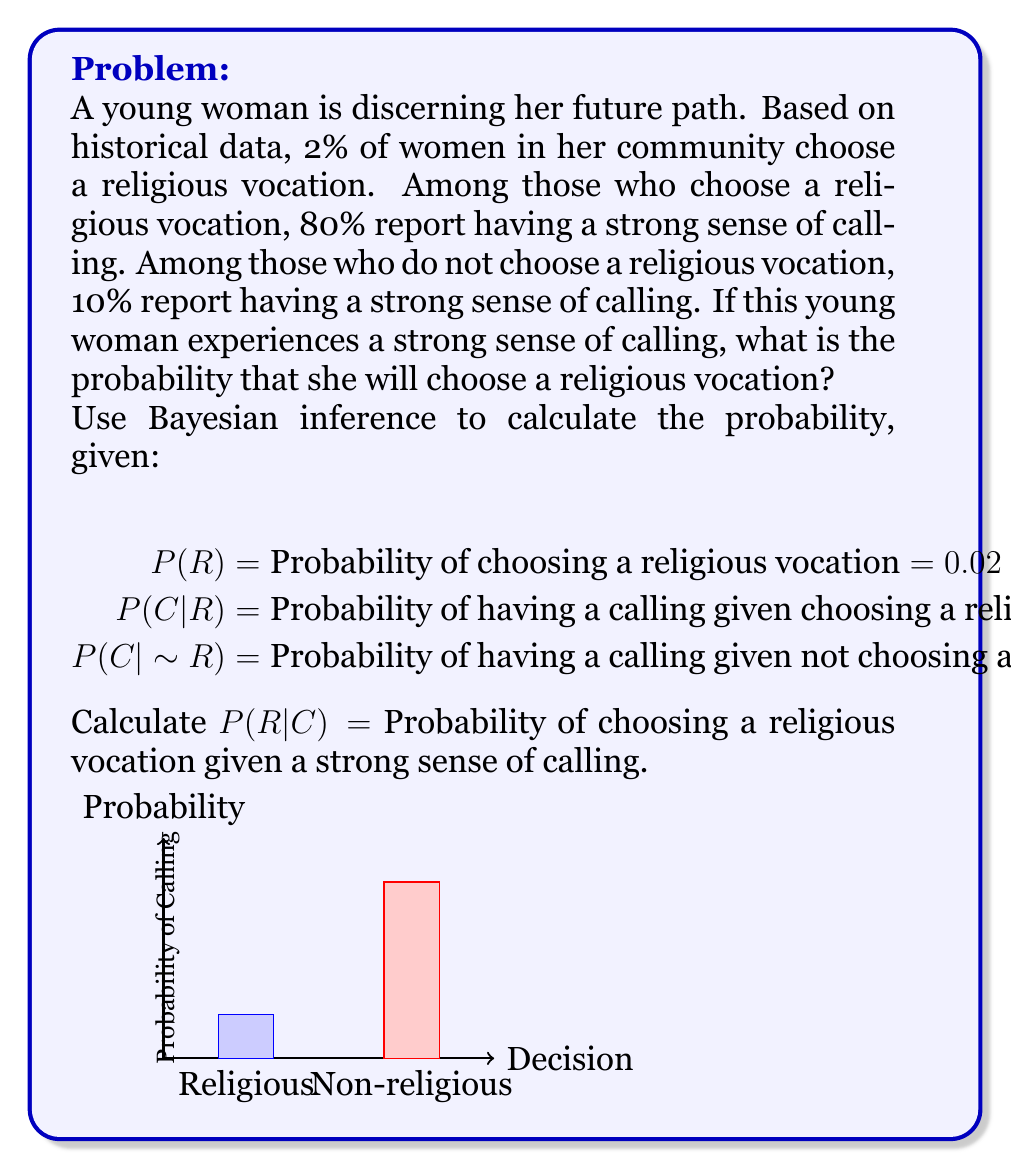Provide a solution to this math problem. To solve this problem using Bayesian inference, we'll use Bayes' theorem:

$$ P(R|C) = \frac{P(C|R) \cdot P(R)}{P(C)} $$

We're given:
P(R) = 0.02
P(C|R) = 0.80
P(C|~R) = 0.10

Step 1: Calculate P(C) using the law of total probability:
$$ P(C) = P(C|R) \cdot P(R) + P(C|~R) \cdot P(~R) $$
$$ P(C) = 0.80 \cdot 0.02 + 0.10 \cdot (1 - 0.02) $$
$$ P(C) = 0.016 + 0.098 = 0.114 $$

Step 2: Apply Bayes' theorem:
$$ P(R|C) = \frac{P(C|R) \cdot P(R)}{P(C)} $$
$$ P(R|C) = \frac{0.80 \cdot 0.02}{0.114} $$
$$ P(R|C) = \frac{0.016}{0.114} \approx 0.1404 $$

Step 3: Convert to percentage:
0.1404 * 100% ≈ 14.04%
Answer: 14.04% 